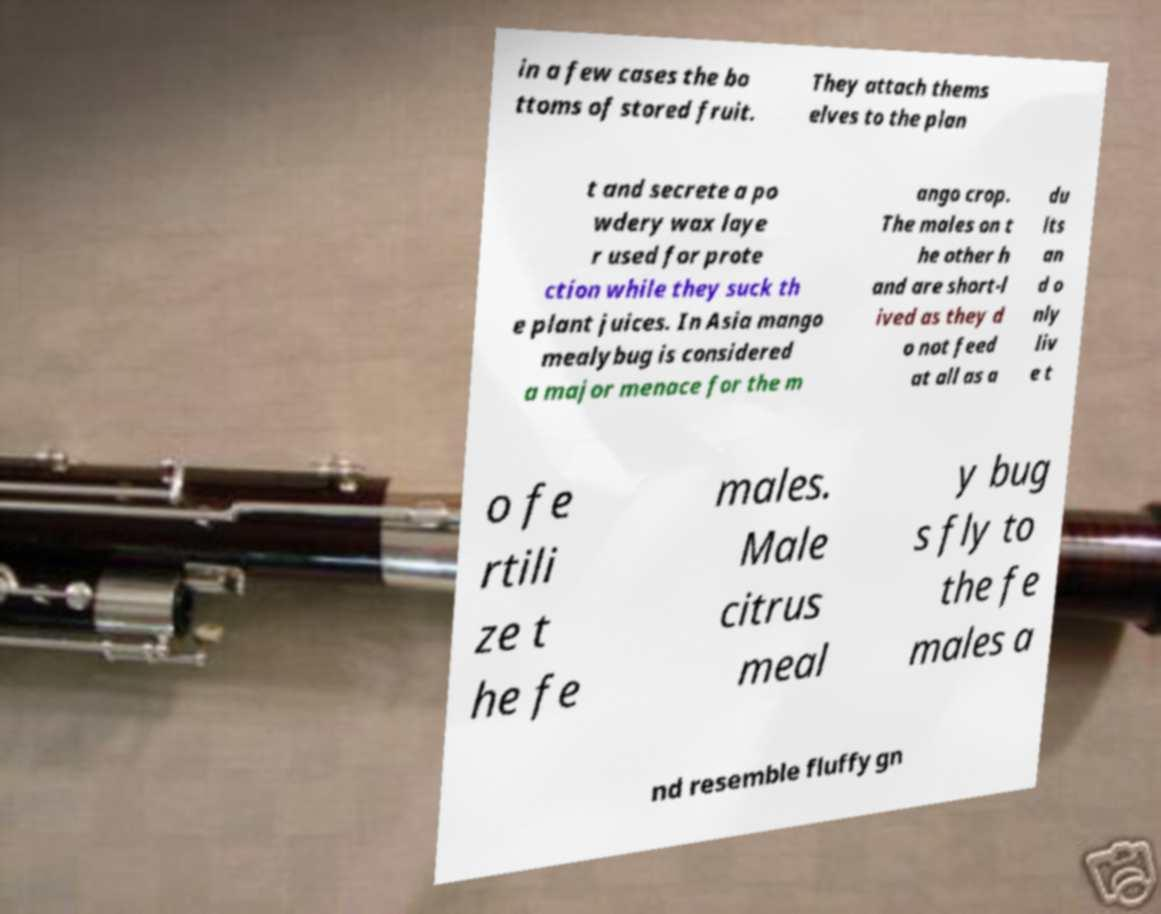Could you extract and type out the text from this image? in a few cases the bo ttoms of stored fruit. They attach thems elves to the plan t and secrete a po wdery wax laye r used for prote ction while they suck th e plant juices. In Asia mango mealybug is considered a major menace for the m ango crop. The males on t he other h and are short-l ived as they d o not feed at all as a du lts an d o nly liv e t o fe rtili ze t he fe males. Male citrus meal y bug s fly to the fe males a nd resemble fluffy gn 